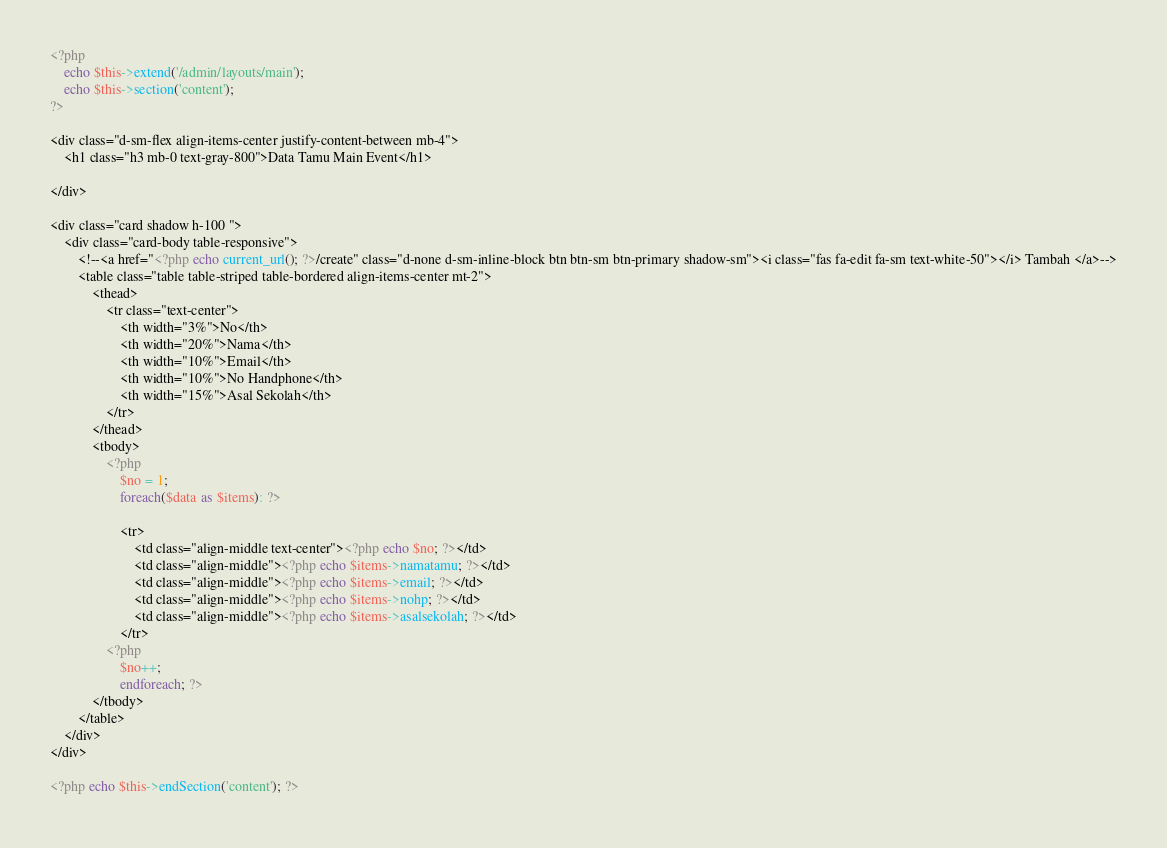Convert code to text. <code><loc_0><loc_0><loc_500><loc_500><_PHP_><?php 
	echo $this->extend('/admin/layouts/main');
    echo $this->section('content');
?>

<div class="d-sm-flex align-items-center justify-content-between mb-4">
    <h1 class="h3 mb-0 text-gray-800">Data Tamu Main Event</h1>
    
</div>

<div class="card shadow h-100 ">
    <div class="card-body table-responsive">
        <!--<a href="<?php echo current_url(); ?>/create" class="d-none d-sm-inline-block btn btn-sm btn-primary shadow-sm"><i class="fas fa-edit fa-sm text-white-50"></i> Tambah </a>-->
        <table class="table table-striped table-bordered align-items-center mt-2">
            <thead>
                <tr class="text-center">
                    <th width="3%">No</th>
                    <th width="20%">Nama</th>
                    <th width="10%">Email</th>
                    <th width="10%">No Handphone</th>
                    <th width="15%">Asal Sekolah</th>
                </tr>
            </thead>
            <tbody>
                <?php 
                    $no = 1;
                    foreach($data as $items): ?>
                    
                    <tr>
                        <td class="align-middle text-center"><?php echo $no; ?></td>
                        <td class="align-middle"><?php echo $items->namatamu; ?></td>
                        <td class="align-middle"><?php echo $items->email; ?></td>
                        <td class="align-middle"><?php echo $items->nohp; ?></td>
                        <td class="align-middle"><?php echo $items->asalsekolah; ?></td>                        
                    </tr>
                <?php 
                    $no++;
                    endforeach; ?>
            </tbody>
        </table>
    </div>
</div>

<?php echo $this->endSection('content'); ?></code> 